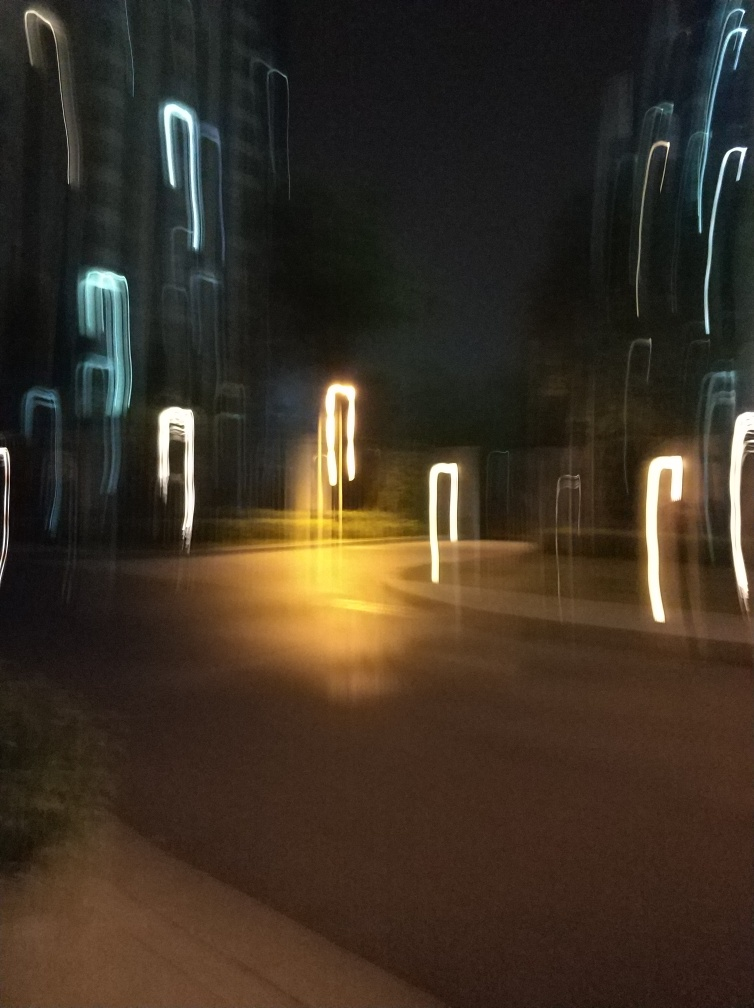Can you suggest how the photo could have been taken more clearly? To take a clearer photo, the photographer could use a faster shutter speed to reduce motion blur. Additionally, using a tripod or stabilizing the camera on a steady surface would help prevent camera shake. Good lighting conditions also contribute to a sharper image. Would changing the ISO setting help as well? Increasing the ISO setting can allow for a faster shutter speed in lower light conditions, which can reduce blur. However, a high ISO can also lead to increased noise in the image, so it's important to find a balance. 